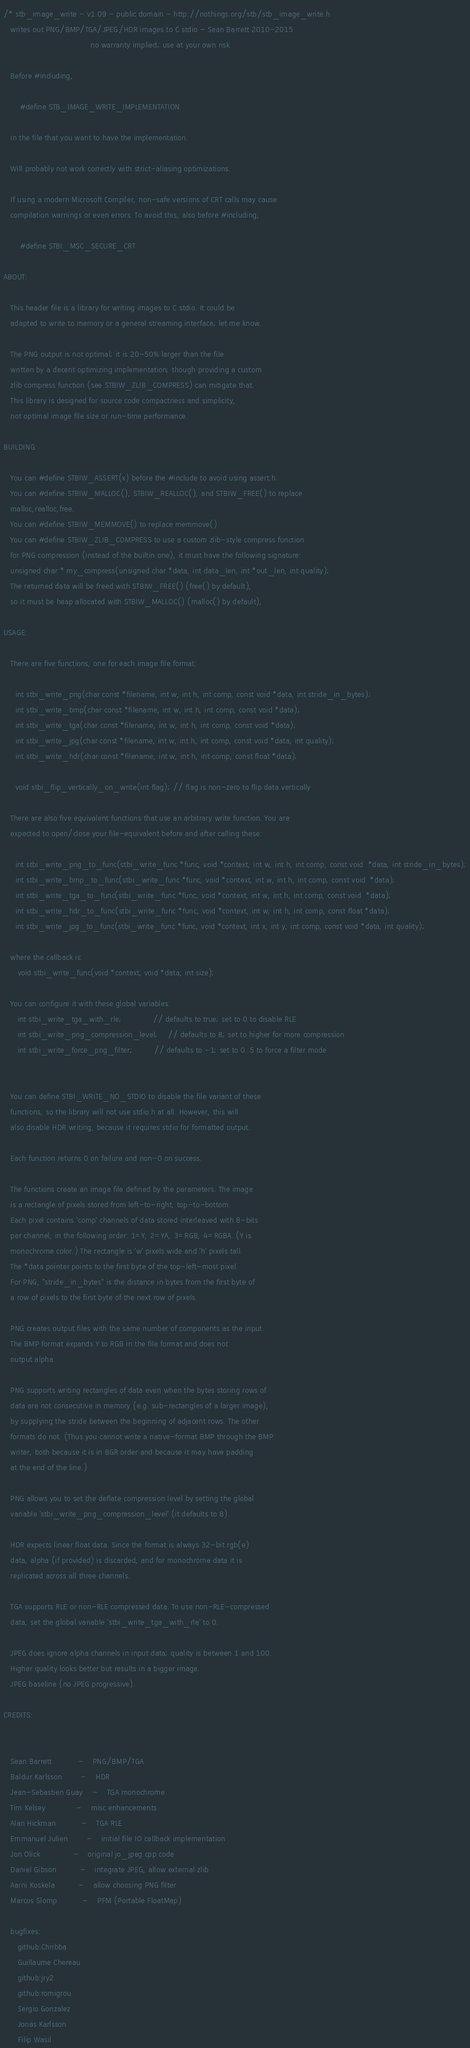<code> <loc_0><loc_0><loc_500><loc_500><_C_>/* stb_image_write - v1.09 - public domain - http://nothings.org/stb/stb_image_write.h
   writes out PNG/BMP/TGA/JPEG/HDR images to C stdio - Sean Barrett 2010-2015
                                     no warranty implied; use at your own risk

   Before #including,

       #define STB_IMAGE_WRITE_IMPLEMENTATION

   in the file that you want to have the implementation.

   Will probably not work correctly with strict-aliasing optimizations.

   If using a modern Microsoft Compiler, non-safe versions of CRT calls may cause 
   compilation warnings or even errors. To avoid this, also before #including,

       #define STBI_MSC_SECURE_CRT

ABOUT:

   This header file is a library for writing images to C stdio. It could be
   adapted to write to memory or a general streaming interface; let me know.

   The PNG output is not optimal; it is 20-50% larger than the file
   written by a decent optimizing implementation; though providing a custom
   zlib compress function (see STBIW_ZLIB_COMPRESS) can mitigate that.
   This library is designed for source code compactness and simplicity,
   not optimal image file size or run-time performance.

BUILDING:

   You can #define STBIW_ASSERT(x) before the #include to avoid using assert.h.
   You can #define STBIW_MALLOC(), STBIW_REALLOC(), and STBIW_FREE() to replace
   malloc,realloc,free.
   You can #define STBIW_MEMMOVE() to replace memmove()
   You can #define STBIW_ZLIB_COMPRESS to use a custom zlib-style compress function
   for PNG compression (instead of the builtin one), it must have the following signature:
   unsigned char * my_compress(unsigned char *data, int data_len, int *out_len, int quality);
   The returned data will be freed with STBIW_FREE() (free() by default),
   so it must be heap allocated with STBIW_MALLOC() (malloc() by default),

USAGE:

   There are five functions, one for each image file format:

     int stbi_write_png(char const *filename, int w, int h, int comp, const void *data, int stride_in_bytes);
     int stbi_write_bmp(char const *filename, int w, int h, int comp, const void *data);
     int stbi_write_tga(char const *filename, int w, int h, int comp, const void *data);
     int stbi_write_jpg(char const *filename, int w, int h, int comp, const void *data, int quality);
     int stbi_write_hdr(char const *filename, int w, int h, int comp, const float *data);

     void stbi_flip_vertically_on_write(int flag); // flag is non-zero to flip data vertically

   There are also five equivalent functions that use an arbitrary write function. You are
   expected to open/close your file-equivalent before and after calling these:

     int stbi_write_png_to_func(stbi_write_func *func, void *context, int w, int h, int comp, const void  *data, int stride_in_bytes);
     int stbi_write_bmp_to_func(stbi_write_func *func, void *context, int w, int h, int comp, const void  *data);
     int stbi_write_tga_to_func(stbi_write_func *func, void *context, int w, int h, int comp, const void  *data);
     int stbi_write_hdr_to_func(stbi_write_func *func, void *context, int w, int h, int comp, const float *data);
     int stbi_write_jpg_to_func(stbi_write_func *func, void *context, int x, int y, int comp, const void *data, int quality);

   where the callback is:
      void stbi_write_func(void *context, void *data, int size);

   You can configure it with these global variables:
      int stbi_write_tga_with_rle;             // defaults to true; set to 0 to disable RLE
      int stbi_write_png_compression_level;    // defaults to 8; set to higher for more compression
      int stbi_write_force_png_filter;         // defaults to -1; set to 0..5 to force a filter mode


   You can define STBI_WRITE_NO_STDIO to disable the file variant of these
   functions, so the library will not use stdio.h at all. However, this will
   also disable HDR writing, because it requires stdio for formatted output.

   Each function returns 0 on failure and non-0 on success.

   The functions create an image file defined by the parameters. The image
   is a rectangle of pixels stored from left-to-right, top-to-bottom.
   Each pixel contains 'comp' channels of data stored interleaved with 8-bits
   per channel, in the following order: 1=Y, 2=YA, 3=RGB, 4=RGBA. (Y is
   monochrome color.) The rectangle is 'w' pixels wide and 'h' pixels tall.
   The *data pointer points to the first byte of the top-left-most pixel.
   For PNG, "stride_in_bytes" is the distance in bytes from the first byte of
   a row of pixels to the first byte of the next row of pixels.

   PNG creates output files with the same number of components as the input.
   The BMP format expands Y to RGB in the file format and does not
   output alpha.

   PNG supports writing rectangles of data even when the bytes storing rows of
   data are not consecutive in memory (e.g. sub-rectangles of a larger image),
   by supplying the stride between the beginning of adjacent rows. The other
   formats do not. (Thus you cannot write a native-format BMP through the BMP
   writer, both because it is in BGR order and because it may have padding
   at the end of the line.)

   PNG allows you to set the deflate compression level by setting the global
   variable 'stbi_write_png_compression_level' (it defaults to 8).

   HDR expects linear float data. Since the format is always 32-bit rgb(e)
   data, alpha (if provided) is discarded, and for monochrome data it is
   replicated across all three channels.

   TGA supports RLE or non-RLE compressed data. To use non-RLE-compressed
   data, set the global variable 'stbi_write_tga_with_rle' to 0.
   
   JPEG does ignore alpha channels in input data; quality is between 1 and 100.
   Higher quality looks better but results in a bigger image.
   JPEG baseline (no JPEG progressive).

CREDITS:


   Sean Barrett           -    PNG/BMP/TGA 
   Baldur Karlsson        -    HDR
   Jean-Sebastien Guay    -    TGA monochrome
   Tim Kelsey             -    misc enhancements
   Alan Hickman           -    TGA RLE
   Emmanuel Julien        -    initial file IO callback implementation
   Jon Olick              -    original jo_jpeg.cpp code
   Daniel Gibson          -    integrate JPEG, allow external zlib
   Aarni Koskela          -    allow choosing PNG filter
   Marcos Slomp           -    PFM (Portable FloatMap)

   bugfixes:
      github:Chribba
      Guillaume Chereau
      github:jry2
      github:romigrou
      Sergio Gonzalez
      Jonas Karlsson
      Filip Wasil</code> 